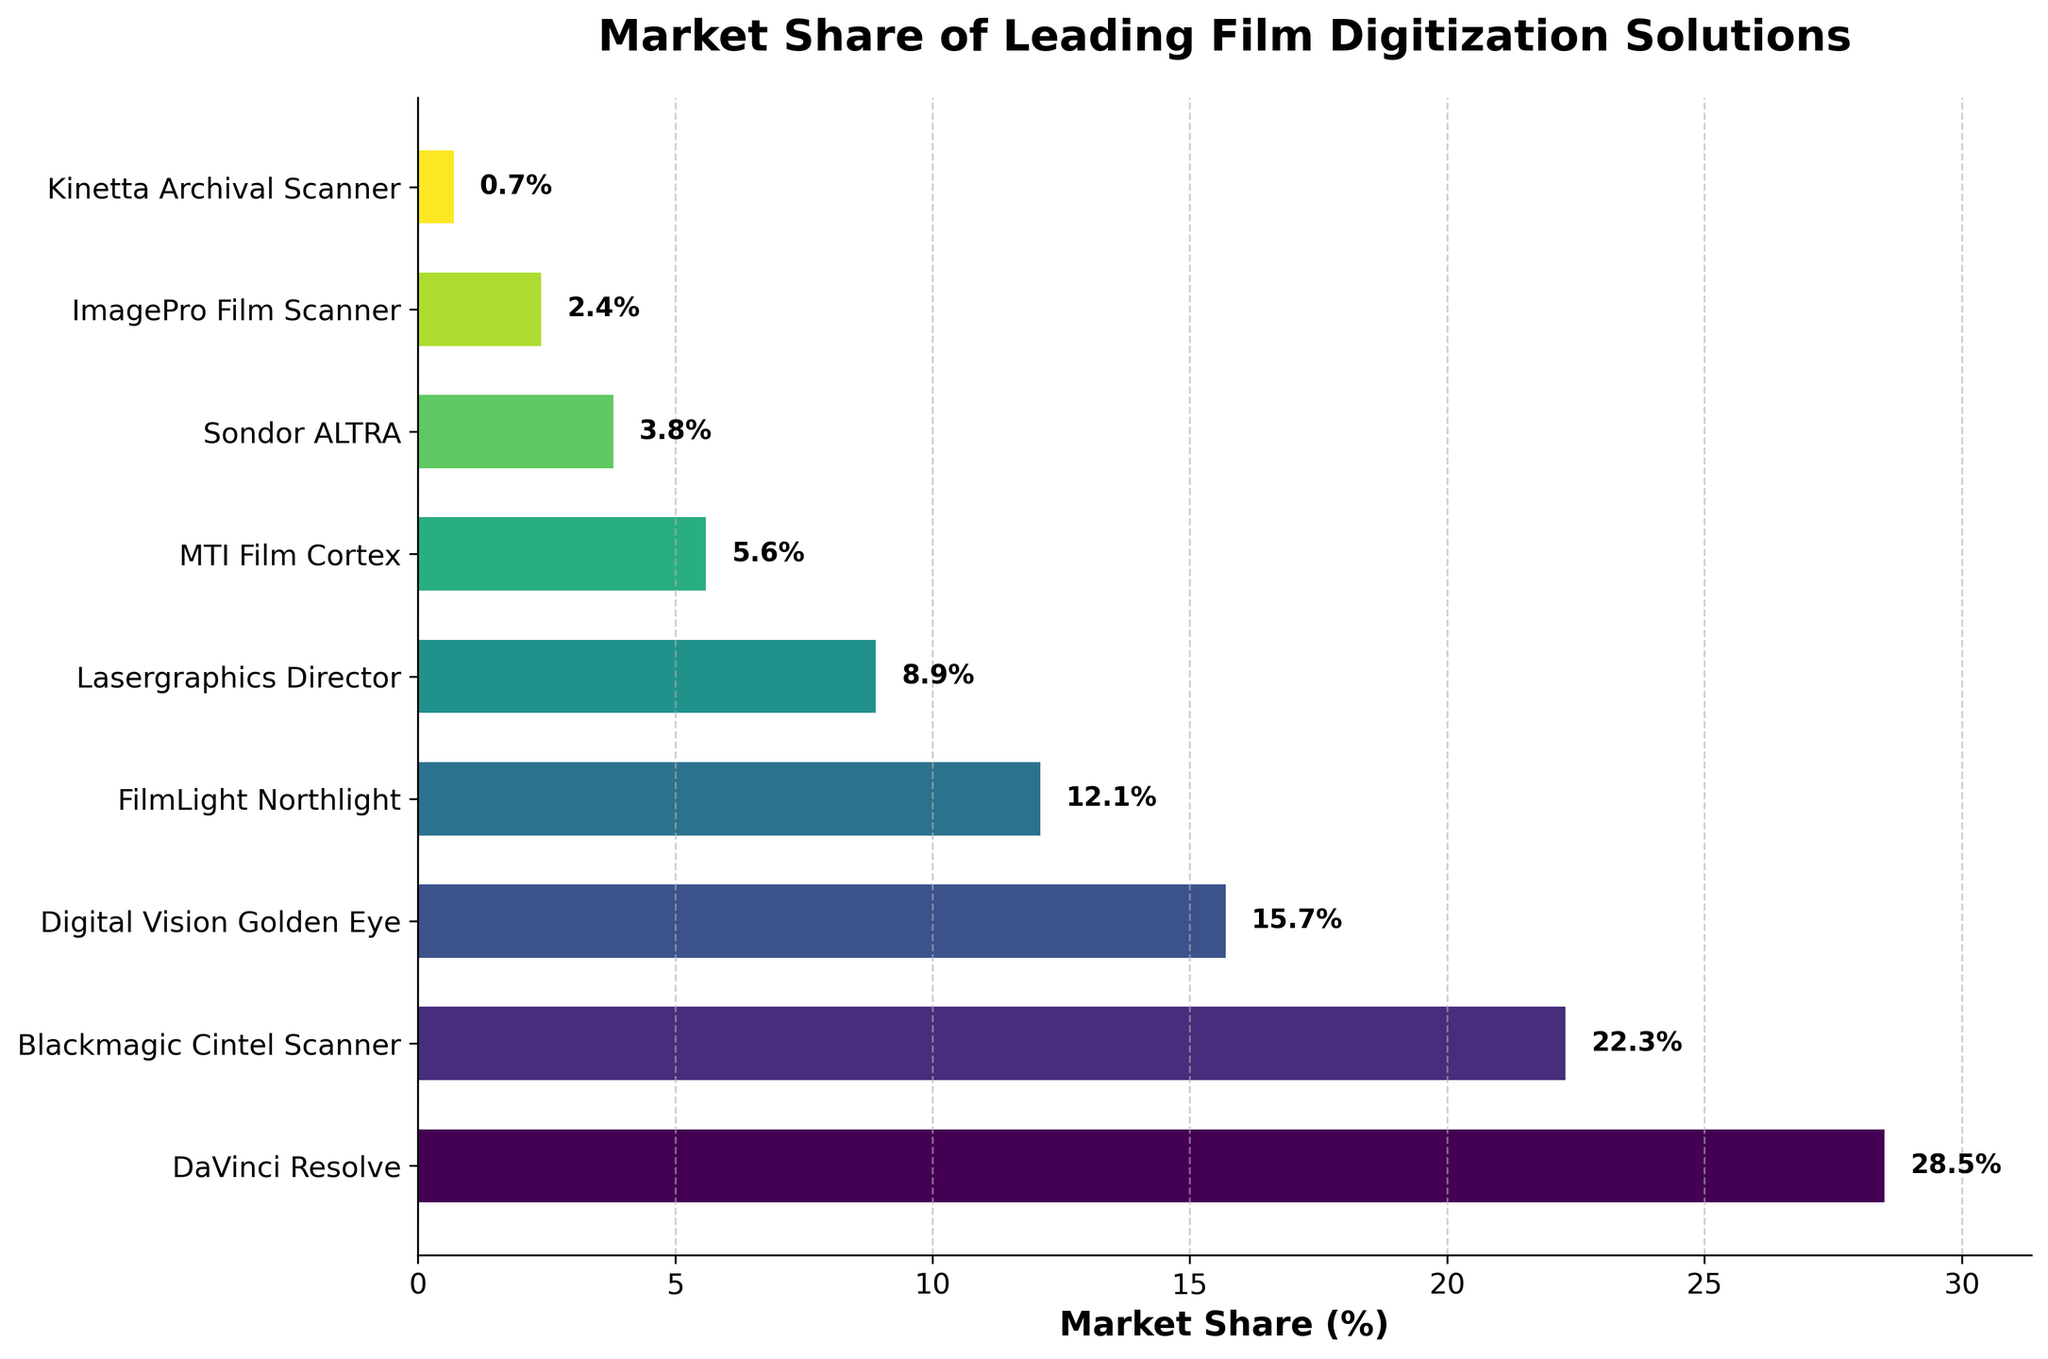How much higher is DaVinci Resolve’s market share compared to Blackmagic Cintel Scanner's? DaVinci Resolve has a market share of 28.5%, and Blackmagic Cintel Scanner has 22.3%. The difference between them is 28.5% - 22.3% = 6.2%.
Answer: 6.2% Which software/hardware has the smallest market share? On the y-axis, the bar representing Kinetta Archival Scanner is the shortest and shows the smallest market share of 0.7%.
Answer: Kinetta Archival Scanner What is the combined market share of Digital Vision Golden Eye and FilmLight Northlight? Digital Vision Golden Eye has a market share of 15.7% and FilmLight Northlight has 12.1%. The combined market share is 15.7% + 12.1% = 27.8%.
Answer: 27.8% Is the market share of Lasergraphics Director greater than the combined market share of Sondor ALTRA and ImagePro Film Scanner? Lasergraphics Director's market share is 8.9%. Sondor ALTRA has 3.8%, and ImagePro Film Scanner has 2.4%. The combined market share of Sondor ALTRA and ImagePro Film Scanner is 3.8% + 2.4% = 6.2%, which is less than 8.9%.
Answer: Yes What is the average market share of the three leading solutions? The three leading solutions are DaVinci Resolve (28.5%), Blackmagic Cintel Scanner (22.3%), and Digital Vision Golden Eye (15.7%). The average market share is calculated as (28.5 + 22.3 + 15.7) / 3 = 22.1667%.
Answer: 22.17% Does any software/hardware have a market share between 10% and 20%? Digital Vision Golden Eye has a market share of 15.7%, FilmLight Northlight has 12.1%, both of which fall between 10% and 20%.
Answer: Yes Which software/hardware has a market share closest to 5%? MTI Film Cortex has a market share of 5.6%, which is the closest to 5% among all the solutions listed.
Answer: MTI Film Cortex What is the difference between the market share of Sondor ALTRA and ImagePro Film Scanner? Sondor ALTRA has a market share of 3.8%, and ImagePro Film Scanner has 2.4%. The difference between their market shares is 3.8% - 2.4% = 1.4%.
Answer: 1.4% Rank the top three solutions by their market share. The top three solutions are DaVinci Resolve (28.5%), Blackmagic Cintel Scanner (22.3%), and Digital Vision Golden Eye (15.7%).
Answer: DaVinci Resolve, Blackmagic Cintel Scanner, Digital Vision Golden Eye How much larger is the market share of DaVinci Resolve compared to Kinetta Archival Scanner? DaVinci Resolve has a market share of 28.5%, and Kinetta Archival Scanner has 0.7%. The difference is 28.5% - 0.7% = 27.8%.
Answer: 27.8% 